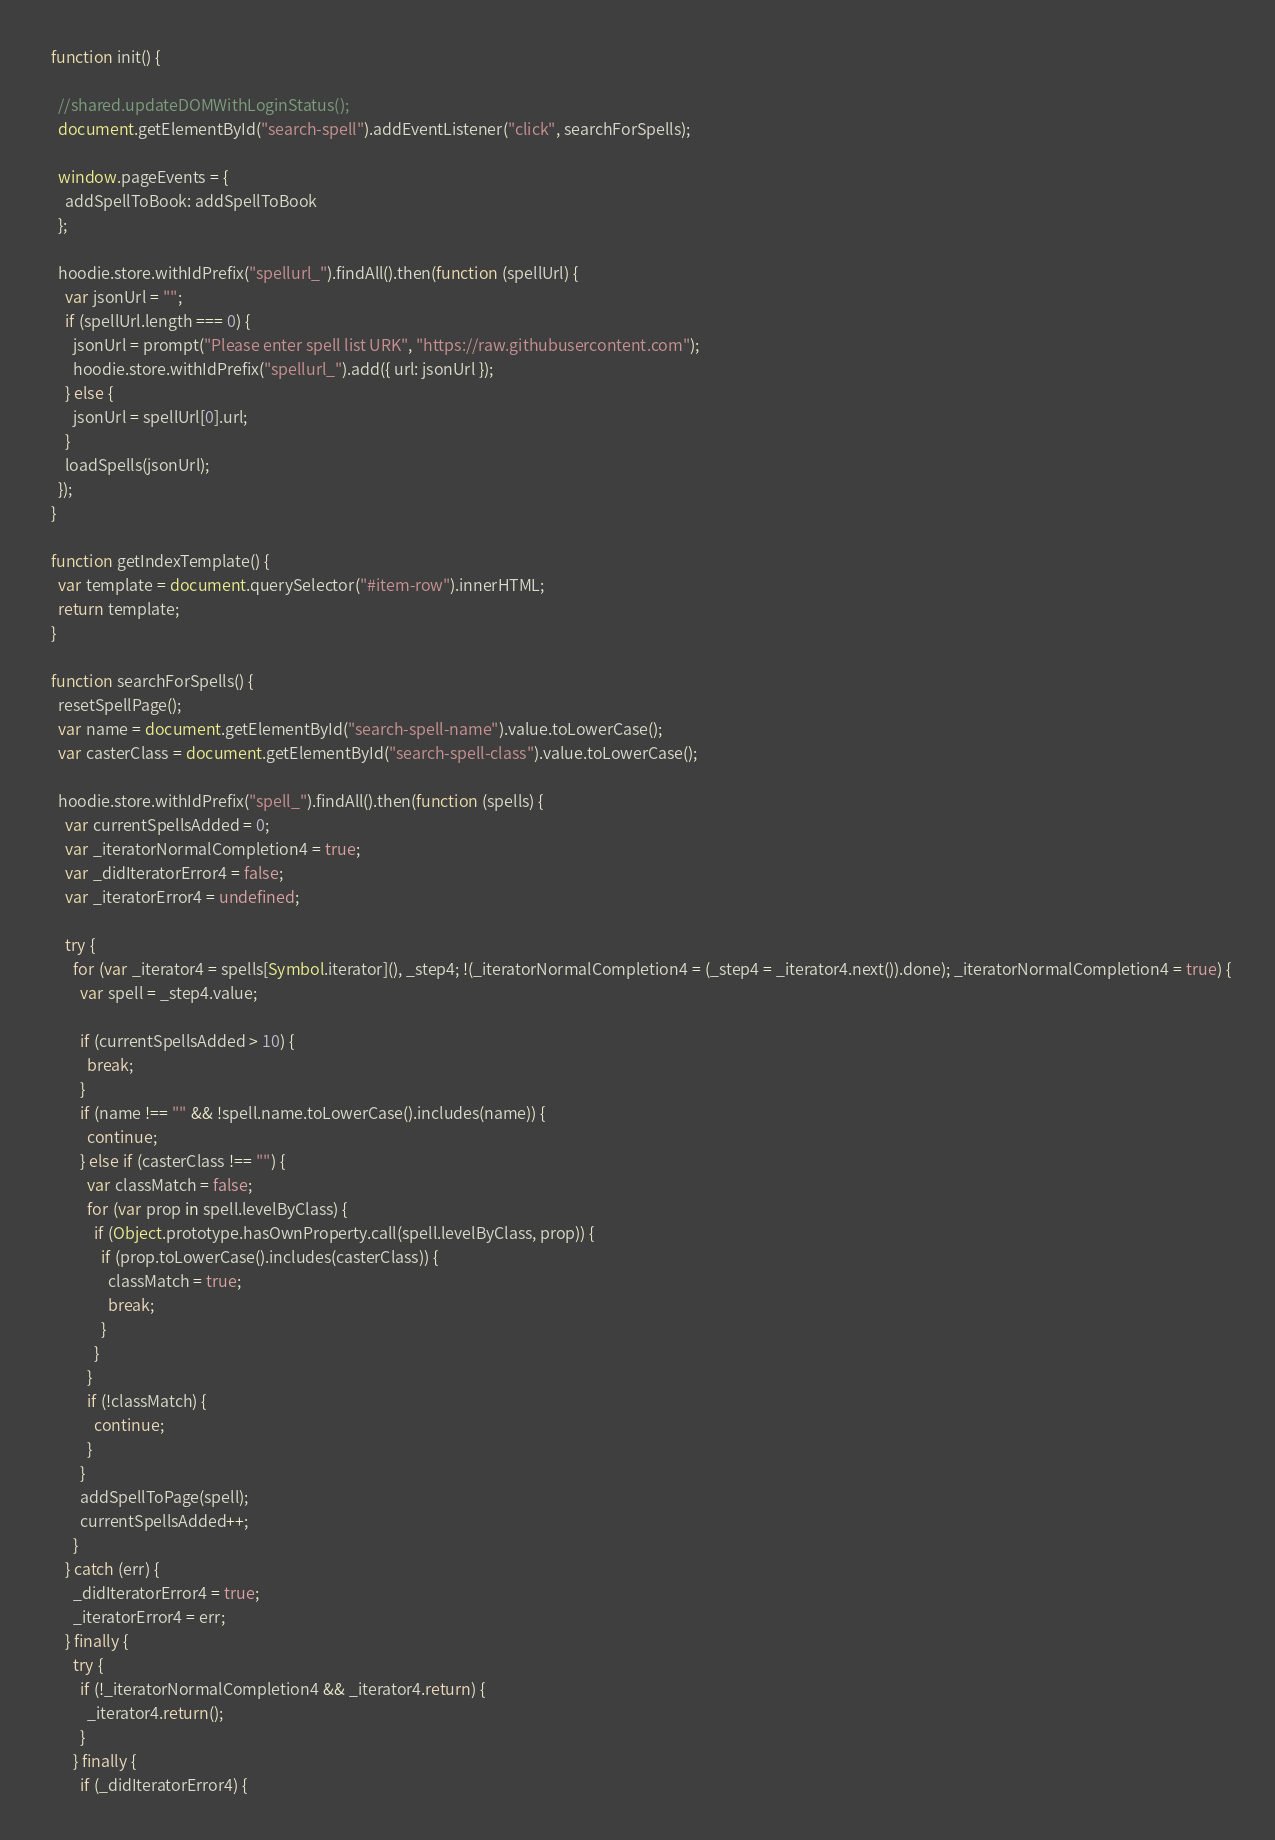<code> <loc_0><loc_0><loc_500><loc_500><_JavaScript_>  function init() {

    //shared.updateDOMWithLoginStatus();
    document.getElementById("search-spell").addEventListener("click", searchForSpells);

    window.pageEvents = {
      addSpellToBook: addSpellToBook
    };

    hoodie.store.withIdPrefix("spellurl_").findAll().then(function (spellUrl) {
      var jsonUrl = "";
      if (spellUrl.length === 0) {
        jsonUrl = prompt("Please enter spell list URK", "https://raw.githubusercontent.com");
        hoodie.store.withIdPrefix("spellurl_").add({ url: jsonUrl });
      } else {
        jsonUrl = spellUrl[0].url;
      }
      loadSpells(jsonUrl);
    });
  }

  function getIndexTemplate() {
    var template = document.querySelector("#item-row").innerHTML;
    return template;
  }

  function searchForSpells() {
    resetSpellPage();
    var name = document.getElementById("search-spell-name").value.toLowerCase();
    var casterClass = document.getElementById("search-spell-class").value.toLowerCase();

    hoodie.store.withIdPrefix("spell_").findAll().then(function (spells) {
      var currentSpellsAdded = 0;
      var _iteratorNormalCompletion4 = true;
      var _didIteratorError4 = false;
      var _iteratorError4 = undefined;

      try {
        for (var _iterator4 = spells[Symbol.iterator](), _step4; !(_iteratorNormalCompletion4 = (_step4 = _iterator4.next()).done); _iteratorNormalCompletion4 = true) {
          var spell = _step4.value;

          if (currentSpellsAdded > 10) {
            break;
          }
          if (name !== "" && !spell.name.toLowerCase().includes(name)) {
            continue;
          } else if (casterClass !== "") {
            var classMatch = false;
            for (var prop in spell.levelByClass) {
              if (Object.prototype.hasOwnProperty.call(spell.levelByClass, prop)) {
                if (prop.toLowerCase().includes(casterClass)) {
                  classMatch = true;
                  break;
                }
              }
            }
            if (!classMatch) {
              continue;
            }
          }
          addSpellToPage(spell);
          currentSpellsAdded++;
        }
      } catch (err) {
        _didIteratorError4 = true;
        _iteratorError4 = err;
      } finally {
        try {
          if (!_iteratorNormalCompletion4 && _iterator4.return) {
            _iterator4.return();
          }
        } finally {
          if (_didIteratorError4) {</code> 